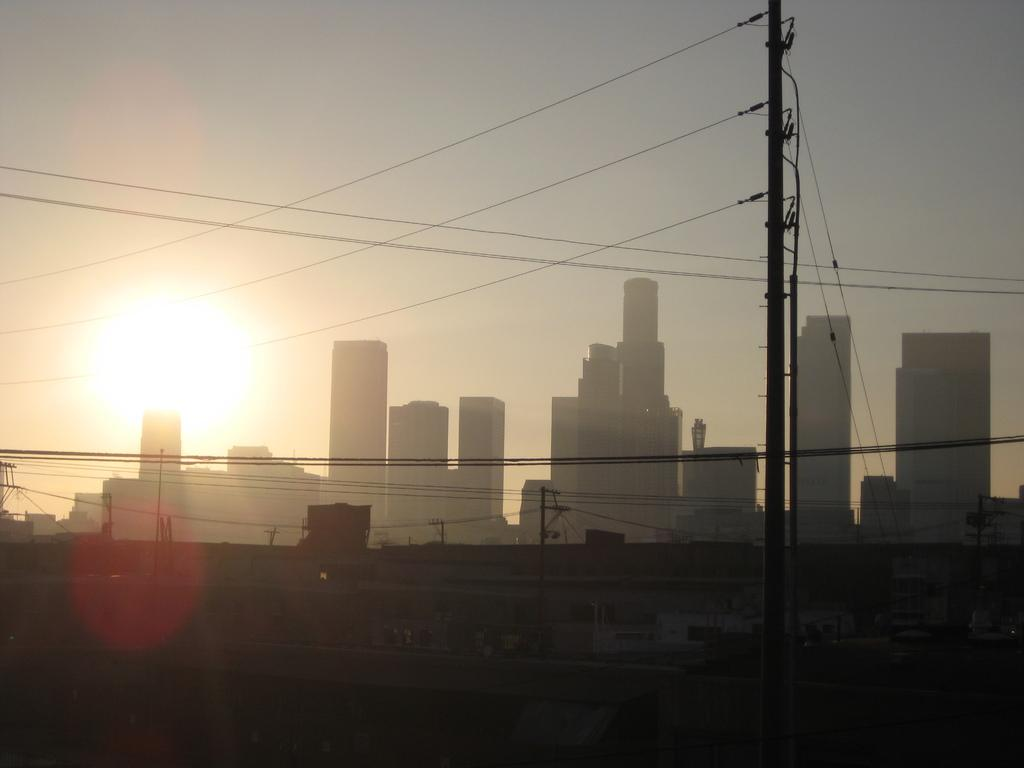What is the main object in the foreground of the image? There is a pole in the image. What else can be seen around the pole in the image? There are many wires in the image. What can be seen in the background of the image? There are more poles, buildings, and the sky visible in the background of the image. Can you describe the celestial body visible in the sky? The sun is visible in the background of the image. How would you describe the overall lighting in the image? The image appears to be a bit dark. How many songs can be heard playing in the background of the image? There are no songs or sounds present in the image, as it is a still photograph. 